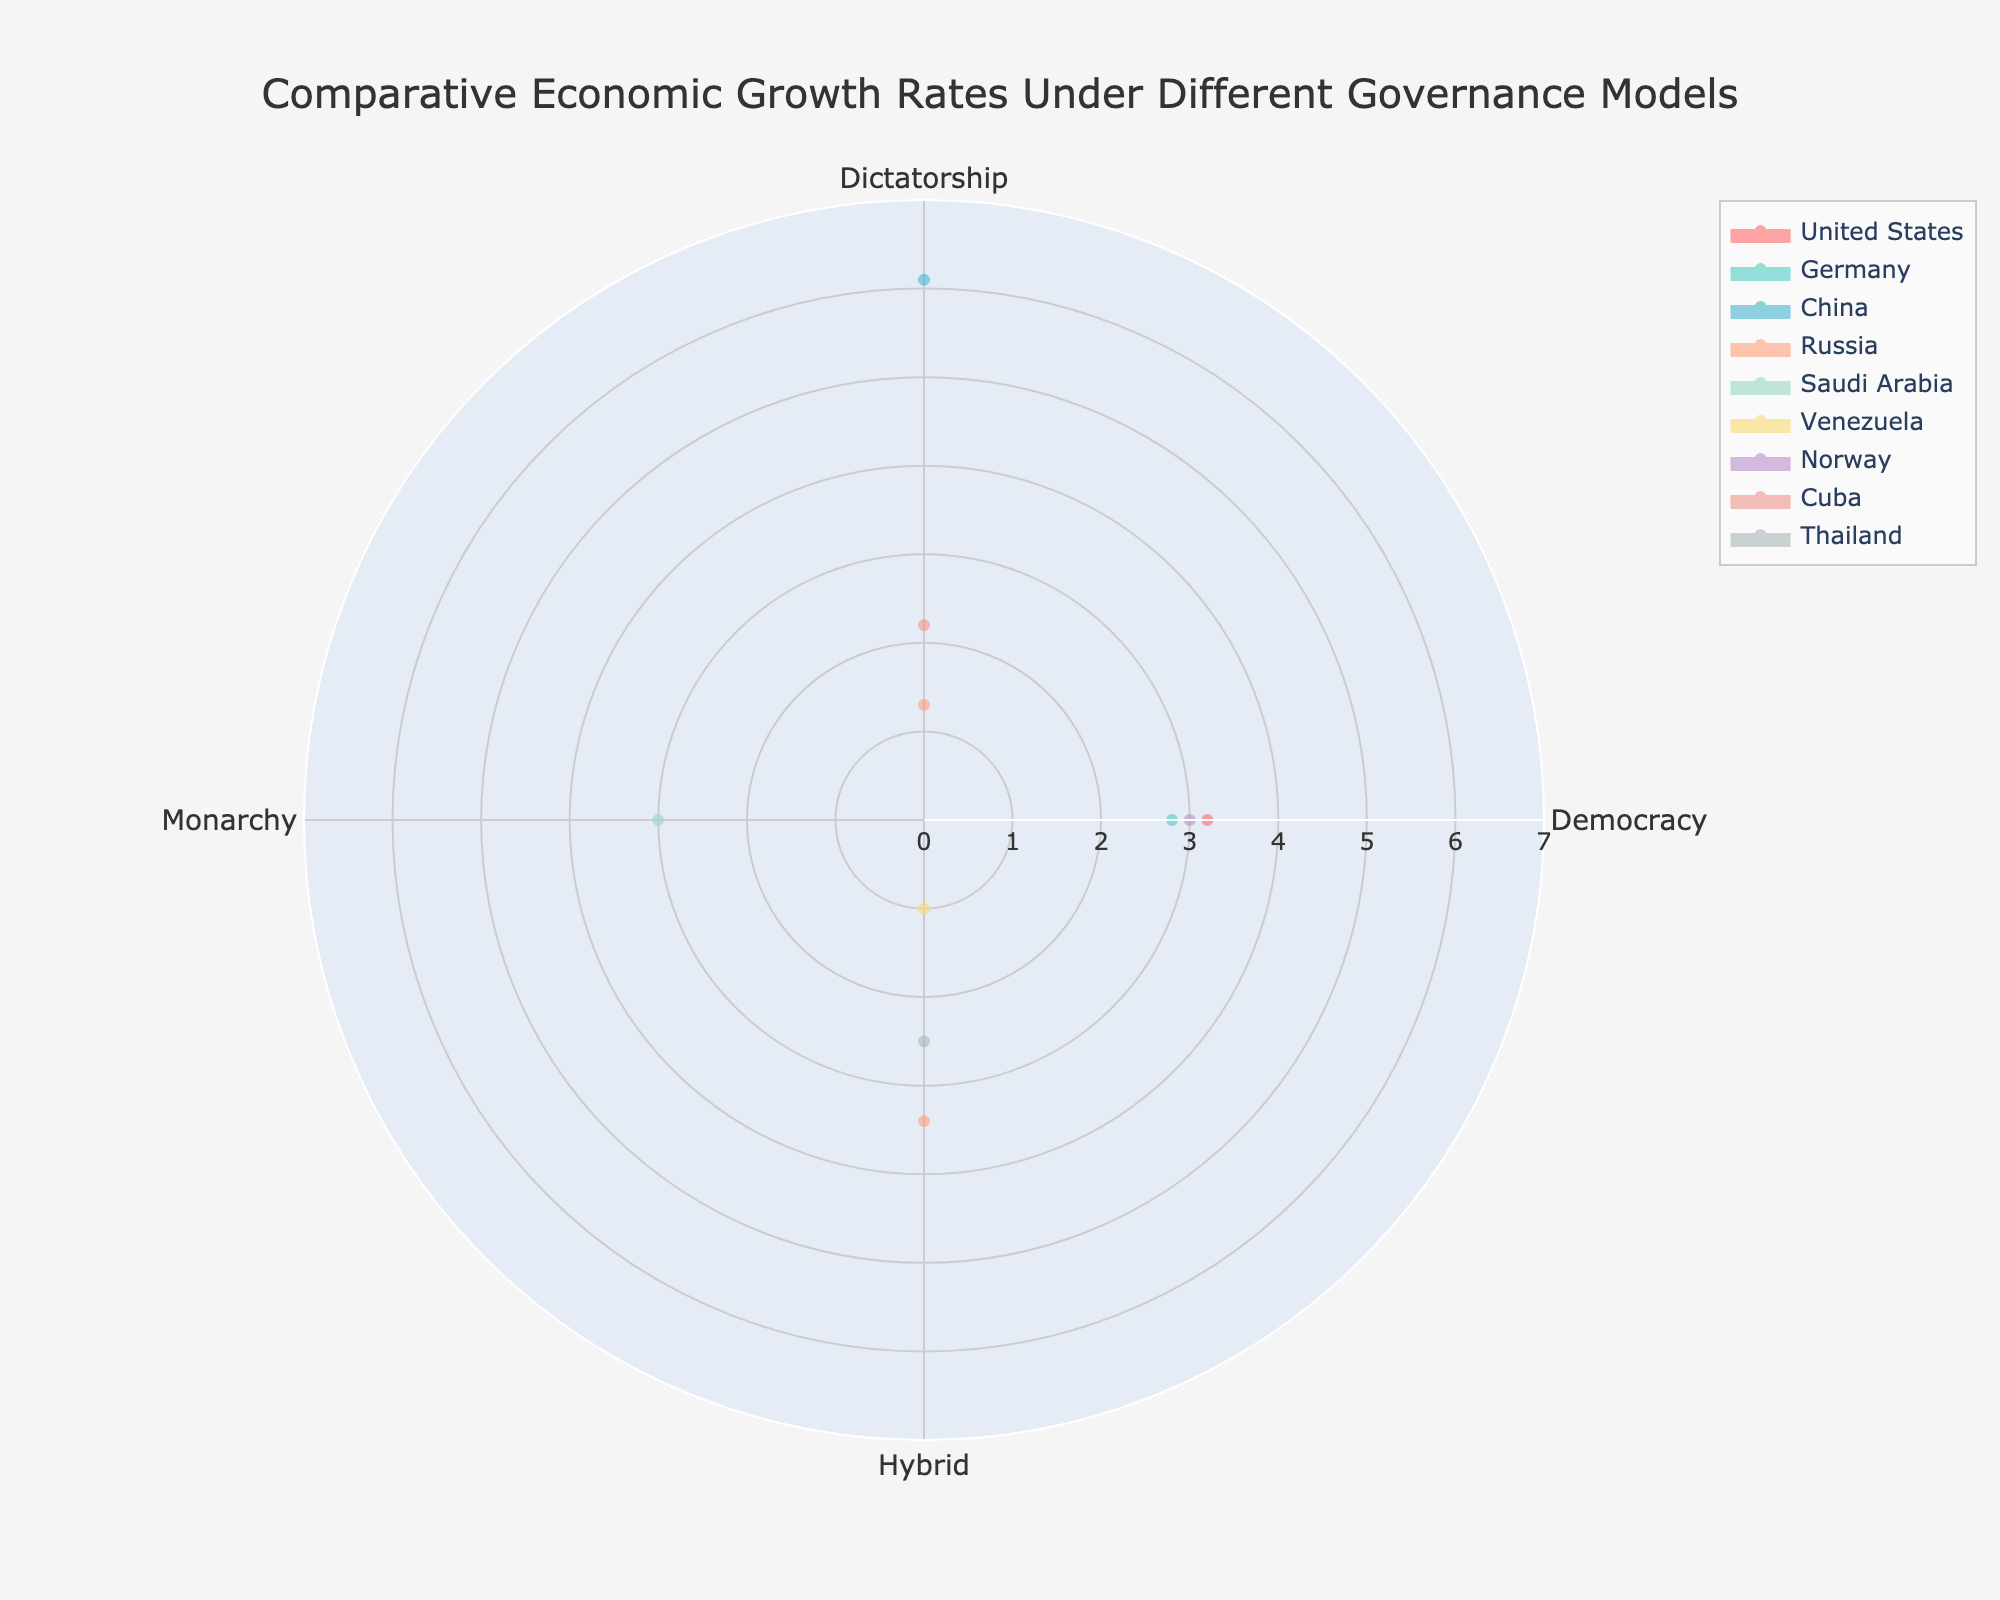What is the title of the radar chart? The title of the chart is typically placed at the top and serves as an overview of what the chart represents. The visual provided in the layout section of the code shows that the title is "Comparative Economic Growth Rates Under Different Governance Models."
Answer: Comparative Economic Growth Rates Under Different Governance Models Which country shows economic growth under a Monarchy governance model? To find this, we need to look at the radar chart's axes and identify which country has a reported value under the Monarchy governance model column. Saudi Arabia is the country shown with economic growth under a Monarchy governance model.
Answer: Saudi Arabia What is the economic growth rate for China under a Dictatorship governance model? In the radar chart, each country's economic growth rate will be represented according to different governance models. By referring to the visual section for China under the Dictatorship governance model, we see that China's growth rate is 6.1.
Answer: 6.1 Which country has the highest economic growth rate under a Democracy governance model? By examining the radar chart’s data for Democracy, we compare the values: the United States (3.2), Germany (2.8), and Norway (3.0). The United States has the highest growth rate in this governance model with 3.2.
Answer: United States How does the economic growth rate of Russia under Hybrid compare to that of Venezuela under Hybrid governance models? We need to compare the economic growth rates from the radar chart of Russia and Venezuela under the Hybrid governance model. Russia's economic growth rate is shown as 3.4, and Venezuela's is shown as 1.0. Therefore, Russia's rate is higher.
Answer: Russia's rate is higher What is the average economic growth rate of countries under a Dictatorship? To calculate the average, sum up the economic growth rates of the countries under Dictatorship and divide by the number of countries showing data. The countries are China (6.1), Russia (1.3), and Cuba (2.2). The average = (6.1 + 1.3 + 2.2) / 3 = 3.2.
Answer: 3.2 Which country has economic growth rates represented under two different governance models, and what are they? We need to look at the radar chart and find the country with values under two different governance models. Russia has values under Dictatorship (1.3) and Hybrid (3.4).
Answer: Russia under Dictatorship and Hybrid By how much does Thailand's economic growth rate under Hybrid governance models differ from Venezuela's? Find the economic growth rates of Thailand and Venezuela under Hybrid governance models. Thailand's rate is 2.5, and Venezuela's rate is 1.0. The difference is 2.5 - 1.0 = 1.5.
Answer: 1.5 